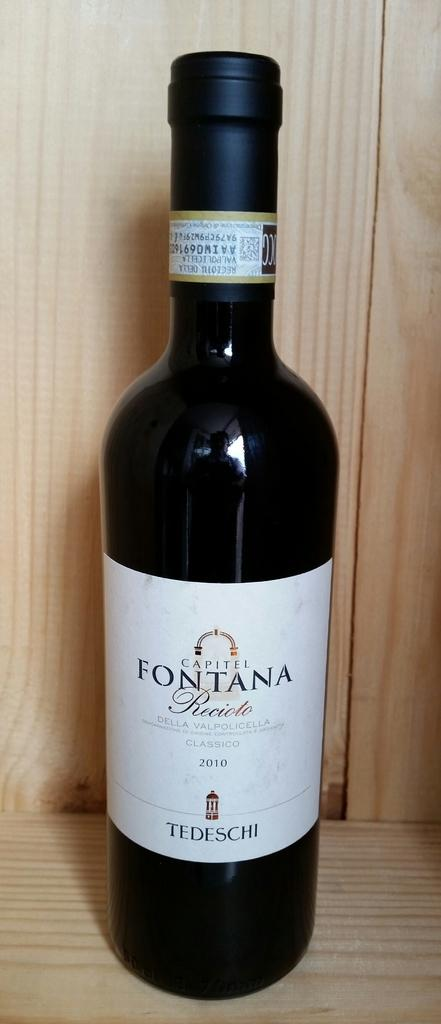<image>
Summarize the visual content of the image. The Fontana bottle is black with a white label. 